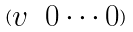Convert formula to latex. <formula><loc_0><loc_0><loc_500><loc_500>( \begin{matrix} v & 0 \cdot \cdot \cdot 0 \end{matrix} )</formula> 